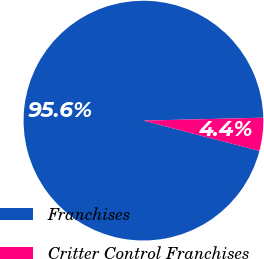Convert chart. <chart><loc_0><loc_0><loc_500><loc_500><pie_chart><fcel>Franchises<fcel>Critter Control Franchises<nl><fcel>95.55%<fcel>4.45%<nl></chart> 